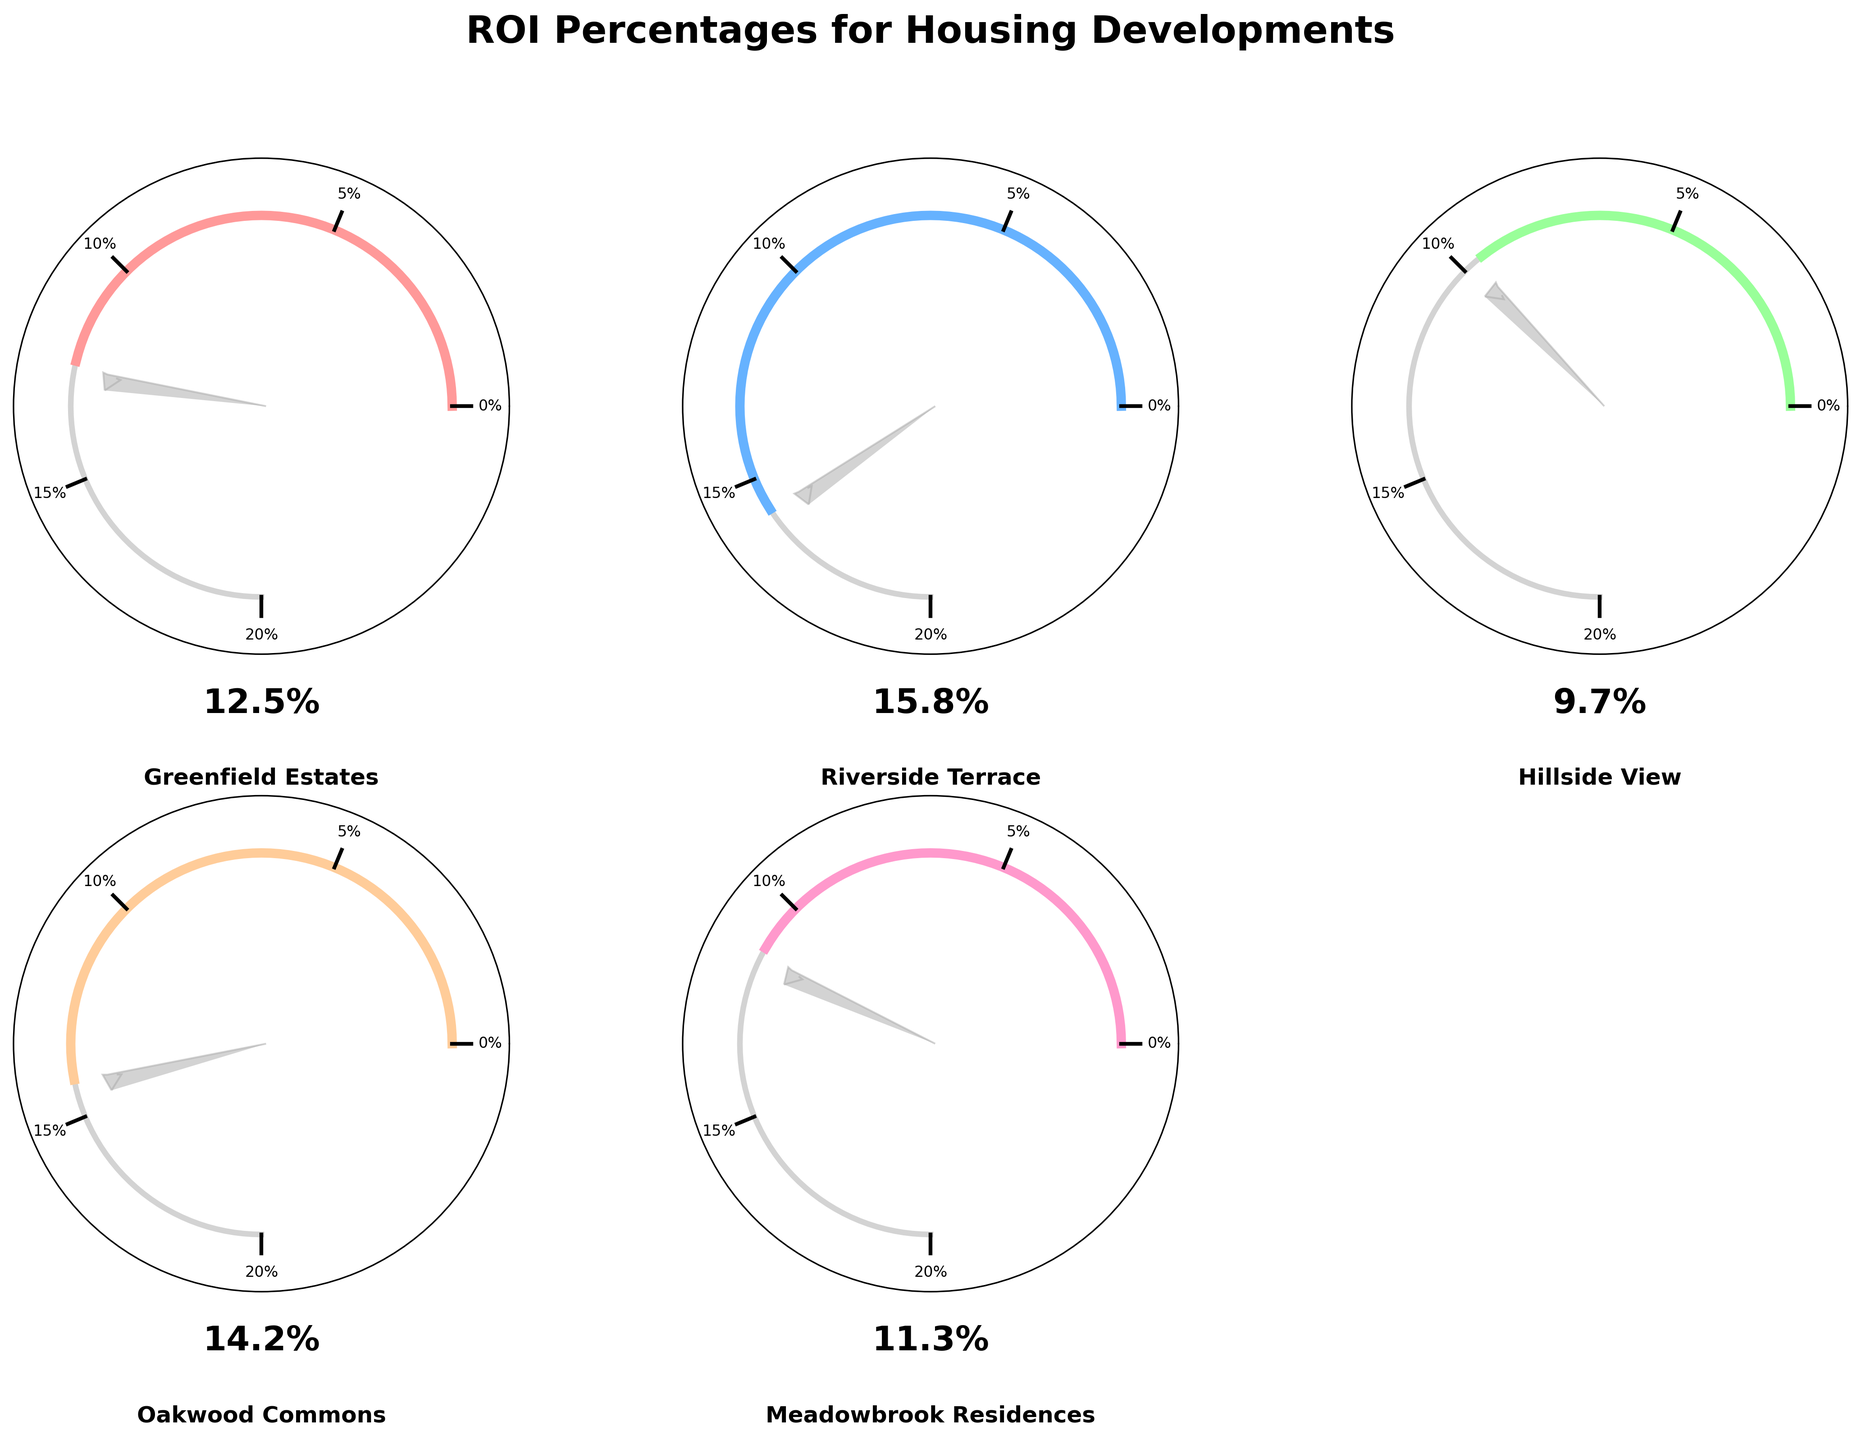What is the highest projected ROI percentage from the housing developments shown in the figure? Find the gauge with the highest needle position and check the ROI percentage text label.
Answer: 15.8% Which housing development has the lowest projected ROI percentage? Identify the gauge with the lowest needle position and ROI percentage text label.
Answer: Hillside View What is the title of the figure? Look at the text at the top of the image.
Answer: ROI Percentages for Housing Developments How many housing developments are displayed in the figure? Count the number of gauges present in the figure.
Answer: 5 What is the color of the gauge with the highest ROI? Find the color of the Riverside Terrace gauge, which has the highest ROI.
Answer: Light blue What's the average ROI percentage across all housing developments? Add all the ROI percentages together and divide by the number of housing developments: (12.5 + 15.8 + 9.7 + 14.2 + 11.3) / 5 = 63.5 / 5.
Answer: 12.7% How much higher is the ROI of Riverside Terrace compared to Hillside View? Subtract the ROI percentage of Hillside View from that of Riverside Terrace: 15.8 - 9.7.
Answer: 6.1 Which project is projected to have an ROI closest to the average ROI? Calculate the deviations from the average ROI (12.7%) for each project, and find the smallest deviation (Oakwood Commons deviates by 1.5%, which is the smallest).
Answer: Oakwood Commons How is the projected ROI visually indicated in each gauge chart? Each gauge needle points to a position corresponding to the ROI as a percentage of the maximum value, and the ROI percentage is written below.
Answer: Needle position and text What is the maximum ROI percentage marked on the gauges? Identify the highest percentage value indicated by ticks on each gauge.
Answer: 20% 